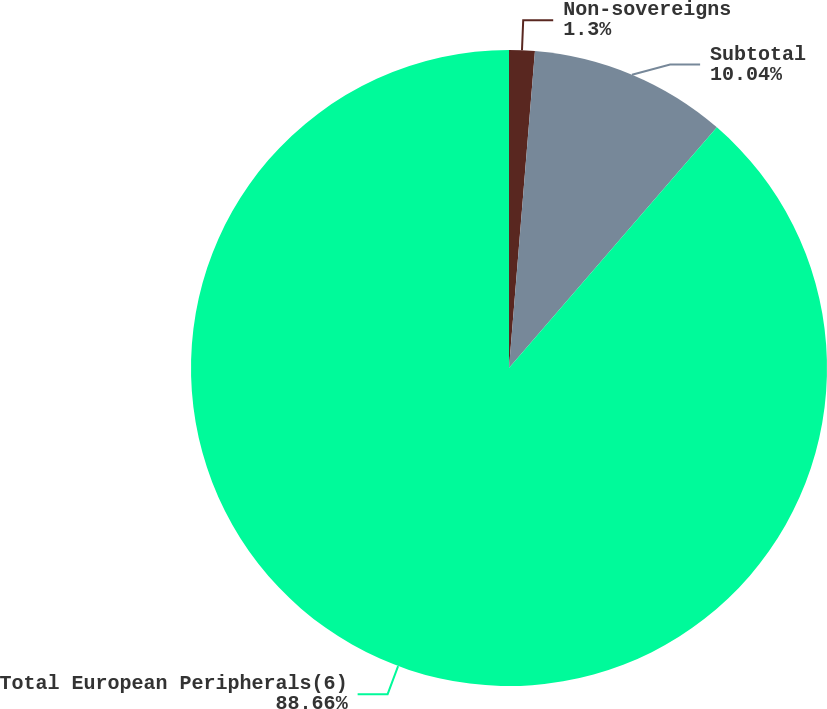<chart> <loc_0><loc_0><loc_500><loc_500><pie_chart><fcel>Non-sovereigns<fcel>Subtotal<fcel>Total European Peripherals(6)<nl><fcel>1.3%<fcel>10.04%<fcel>88.66%<nl></chart> 